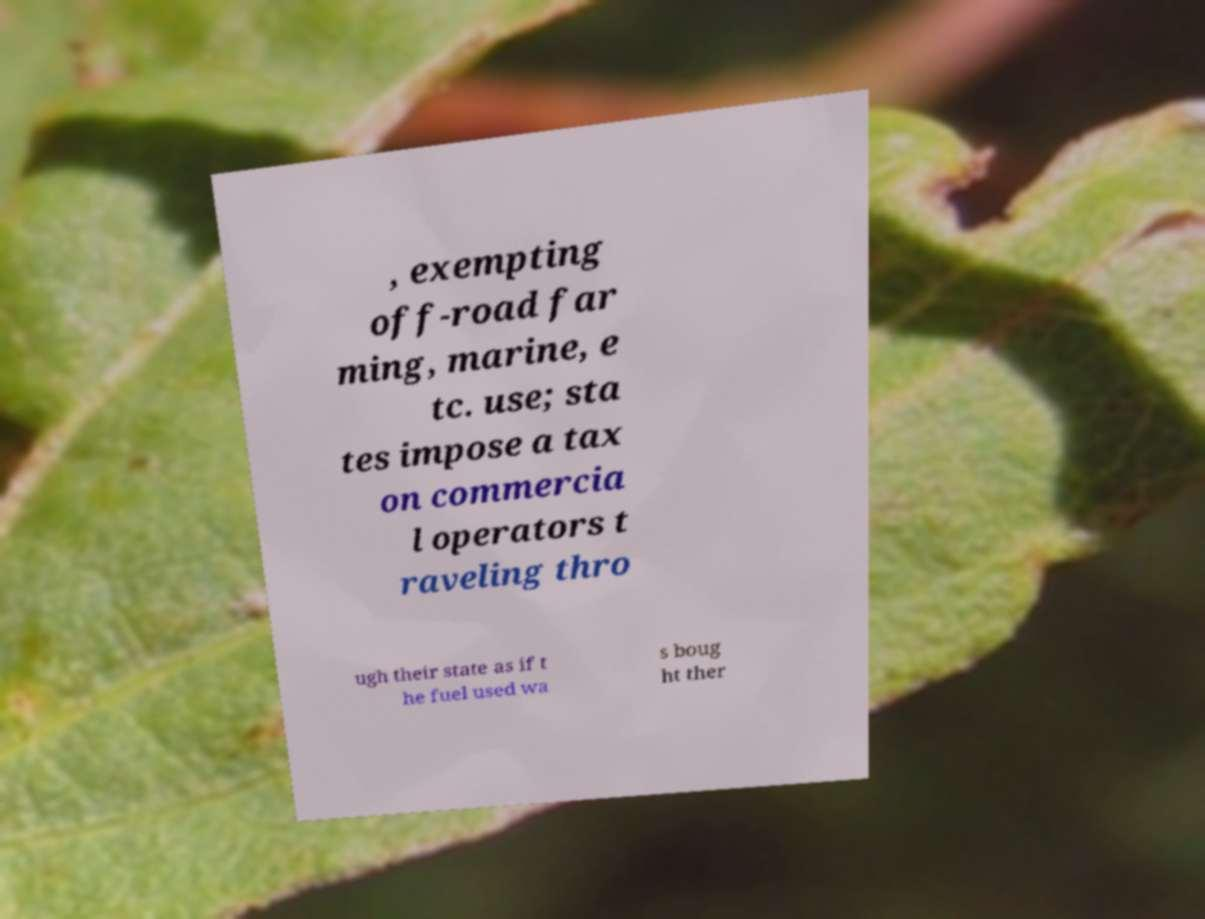For documentation purposes, I need the text within this image transcribed. Could you provide that? , exempting off-road far ming, marine, e tc. use; sta tes impose a tax on commercia l operators t raveling thro ugh their state as if t he fuel used wa s boug ht ther 